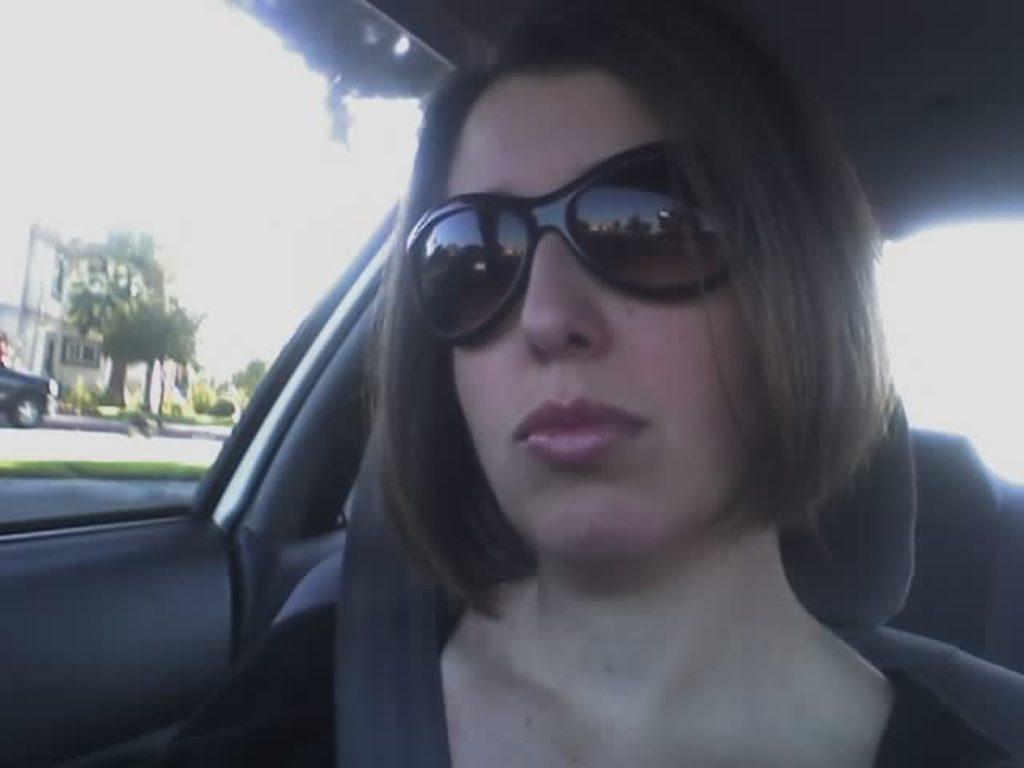Could you give a brief overview of what you see in this image? In the center of the image we can see a lady is sitting in a vehicle and wearing a dress, seatbelt, goggles. In the background of the image we can see the windows. Through the window we can see a building, trees, vehicles, road, grass and sky. 